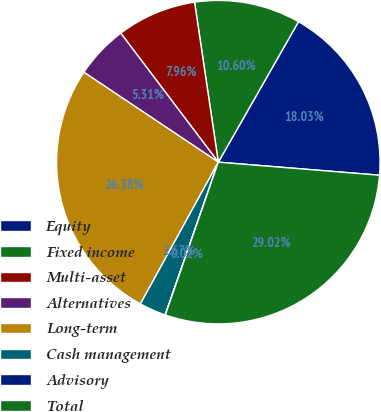<chart> <loc_0><loc_0><loc_500><loc_500><pie_chart><fcel>Equity<fcel>Fixed income<fcel>Multi-asset<fcel>Alternatives<fcel>Long-term<fcel>Cash management<fcel>Advisory<fcel>Total<nl><fcel>18.03%<fcel>10.6%<fcel>7.96%<fcel>5.31%<fcel>26.38%<fcel>2.67%<fcel>0.02%<fcel>29.02%<nl></chart> 